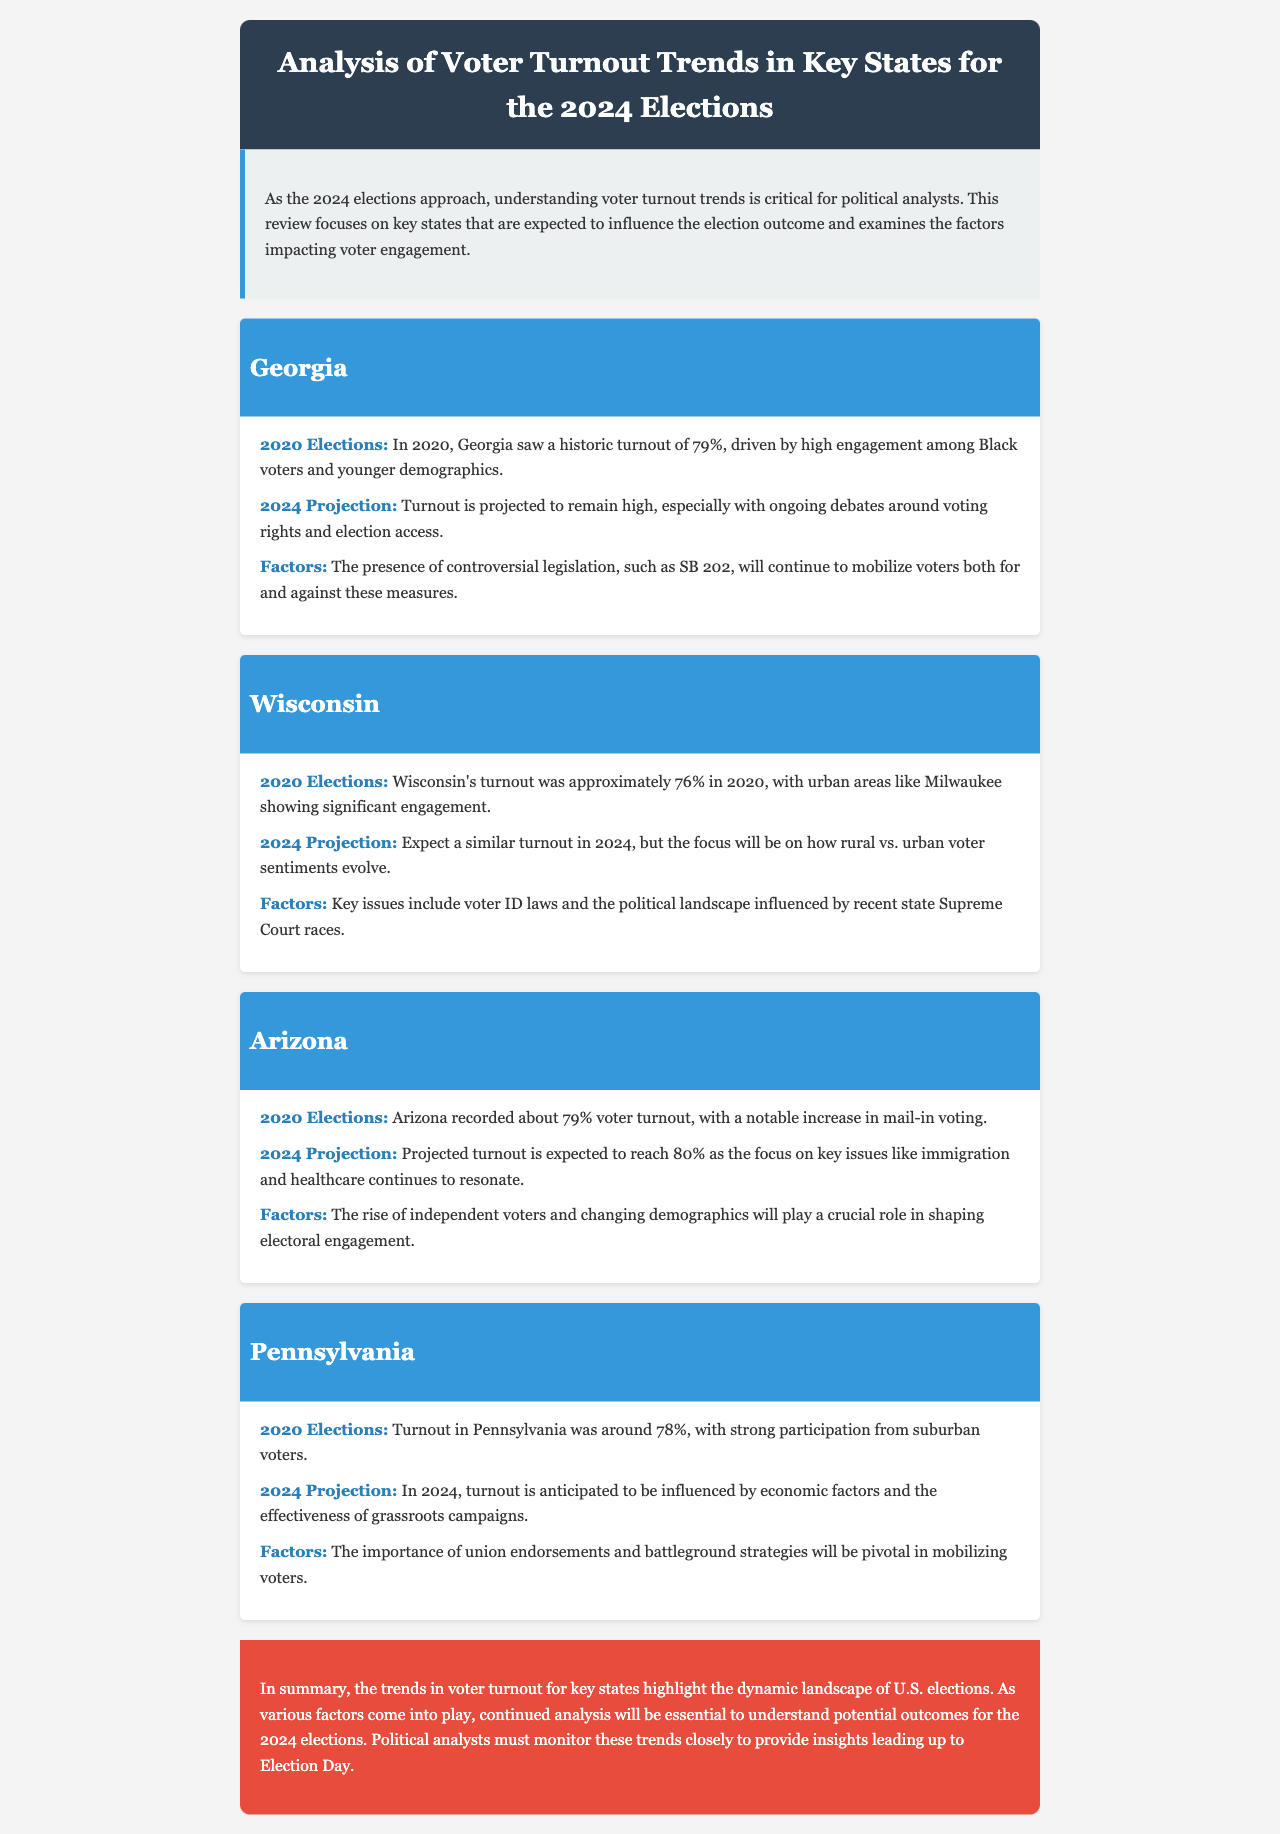what was Georgia's voter turnout in 2020? Georgia's turnout in 2020 was 79%, as stated in the section about Georgia.
Answer: 79% what is projected voter turnout for Arizona in 2024? The projected turnout for Arizona in 2024 is 80%, according to the trends listed for Arizona.
Answer: 80% which demographic significantly contributed to Georgia's 2020 turnout? The significant contributor to Georgia's 2020 turnout was Black voters, as mentioned in the trends for Georgia.
Answer: Black voters what is a key issue affecting voter turnout in Wisconsin? Voter ID laws are a key issue influencing voter turnout in Wisconsin, as indicated in the trends section for that state.
Answer: Voter ID laws what role do union endorsements play in Pennsylvania's 2024 elections? Union endorsements are pivotal in mobilizing voters in Pennsylvania, as noted in the factors affecting turnout there.
Answer: Pivotal what trend is expected in Wisconsin regarding urban vs. rural voters? The trend expected in Wisconsin is how rural vs. urban voter sentiments evolve, highlighted in the projected turnout for the state.
Answer: Evolve what is one factor influencing Arizona voter turnout? One factor influencing Arizona's voter turnout is the rise of independent voters, as mentioned in the factors impacting turnout in Arizona.
Answer: Rise of independent voters what election year had a high turnout driven by younger demographics in Georgia? The election year with high turnout driven by younger demographics in Georgia was 2020, according to the trends for that state.
Answer: 2020 